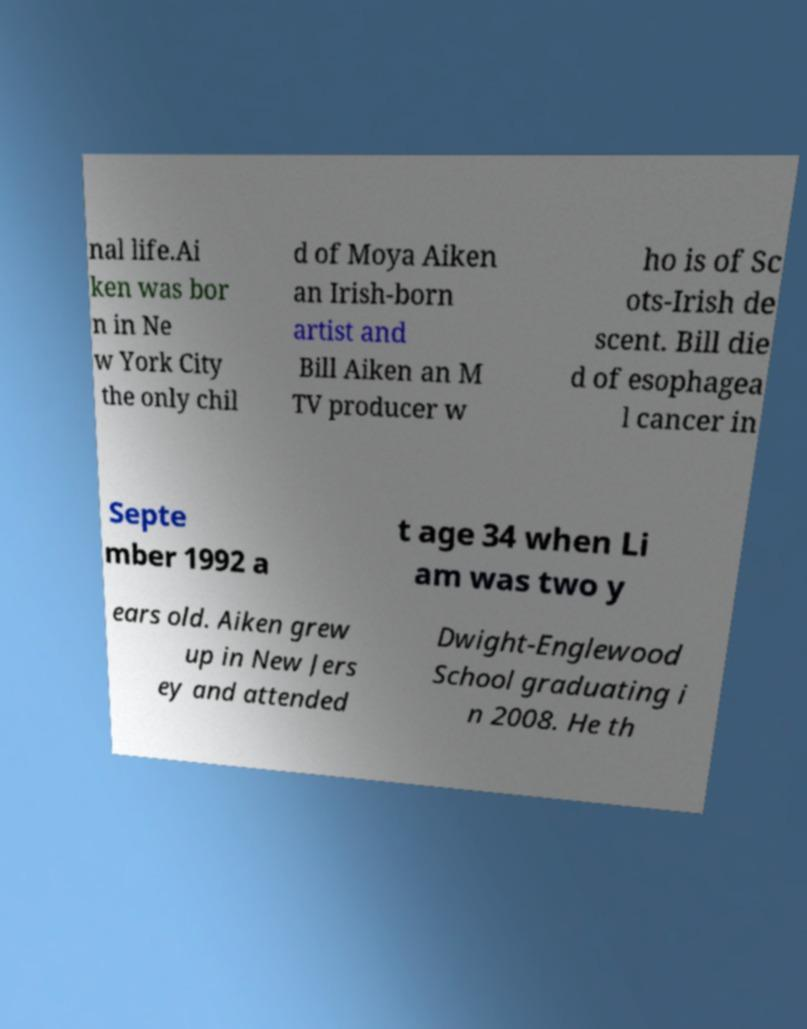Please identify and transcribe the text found in this image. nal life.Ai ken was bor n in Ne w York City the only chil d of Moya Aiken an Irish-born artist and Bill Aiken an M TV producer w ho is of Sc ots-Irish de scent. Bill die d of esophagea l cancer in Septe mber 1992 a t age 34 when Li am was two y ears old. Aiken grew up in New Jers ey and attended Dwight-Englewood School graduating i n 2008. He th 